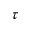<formula> <loc_0><loc_0><loc_500><loc_500>\tau</formula> 